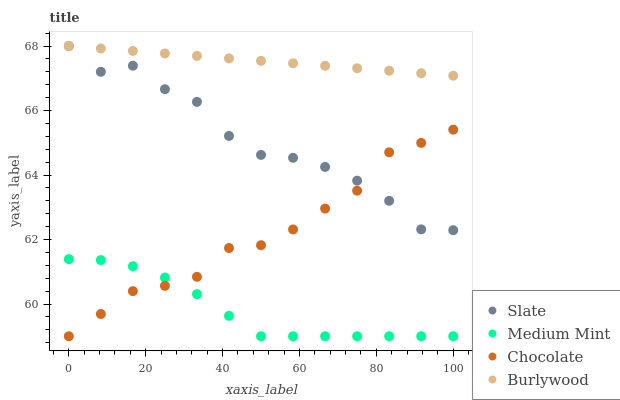Does Medium Mint have the minimum area under the curve?
Answer yes or no. Yes. Does Burlywood have the maximum area under the curve?
Answer yes or no. Yes. Does Slate have the minimum area under the curve?
Answer yes or no. No. Does Slate have the maximum area under the curve?
Answer yes or no. No. Is Burlywood the smoothest?
Answer yes or no. Yes. Is Slate the roughest?
Answer yes or no. Yes. Is Slate the smoothest?
Answer yes or no. No. Is Burlywood the roughest?
Answer yes or no. No. Does Medium Mint have the lowest value?
Answer yes or no. Yes. Does Slate have the lowest value?
Answer yes or no. No. Does Slate have the highest value?
Answer yes or no. Yes. Does Chocolate have the highest value?
Answer yes or no. No. Is Chocolate less than Burlywood?
Answer yes or no. Yes. Is Slate greater than Medium Mint?
Answer yes or no. Yes. Does Chocolate intersect Slate?
Answer yes or no. Yes. Is Chocolate less than Slate?
Answer yes or no. No. Is Chocolate greater than Slate?
Answer yes or no. No. Does Chocolate intersect Burlywood?
Answer yes or no. No. 